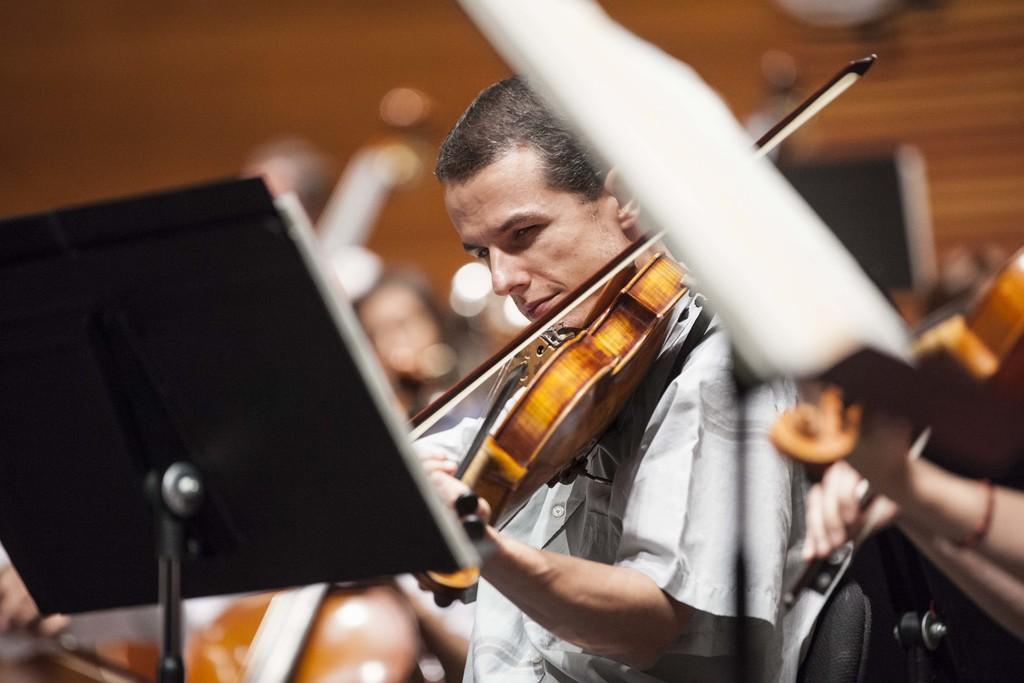Could you give a brief overview of what you see in this image? In this picture there is some man holding a violin his hands and playing it. In front of him there is stand for placing the book. In the background we can observe a wall here. 